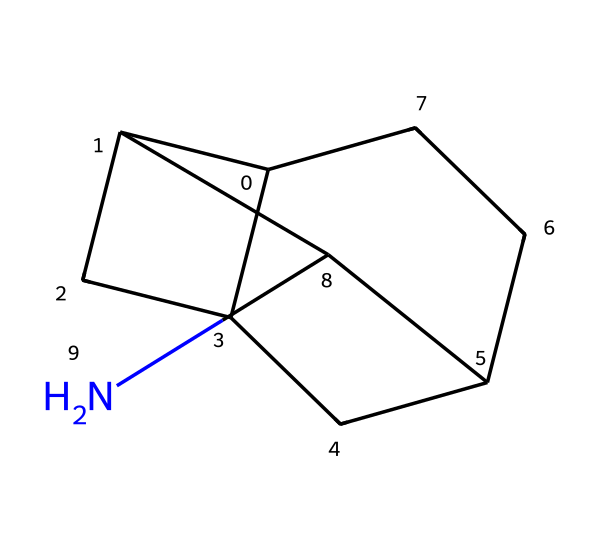What is the total number of carbon atoms in the compound? By analyzing the SMILES representation, we identify that there are 10 carbon atoms present in the structure. The 'C' represents carbon, and counting all distinct occurrences gives us the total.
Answer: 10 How many nitrogen atoms are in the compound? The SMILES notation indicates the presence of a single nitrogen atom, represented by 'N'. Therefore, counting yields one nitrogen atom in the structure.
Answer: 1 What type of chemical structure does this compound represent? The structure shows a polycyclic compound with a cage-like geometry, typical of adamantane derivatives. This classification is based on the arrangement of carbon atoms fused in multiple rings.
Answer: adamantane Is this compound likely to be water-soluble? Given the hydrophobic nature of cage compounds like adamantane derivatives, which lack polar functional groups, we can deduce that this compound would not dissolve well in water.
Answer: no What is the degree of saturation for the compound represented? The number of rings and single bonds present in the chemical structure indicates high saturation with minimal unsaturation. Subsequently, this structure is completely saturated, allowing no additional double or triple bonds.
Answer: saturated Which atom determines the basic alkaline nature of the compound? The nitrogen atom present in the structure is typically responsible for introducing basicity due to its lone pair, which can accept protons. Thus, the nitrogen contributes to making the compound somewhat basic.
Answer: nitrogen How many ring systems are present in the chemical structure? By evaluating the SMILES notation, we can see that there are three interconnected ring systems within the compound, characteristic of its complex cage structure.
Answer: 3 